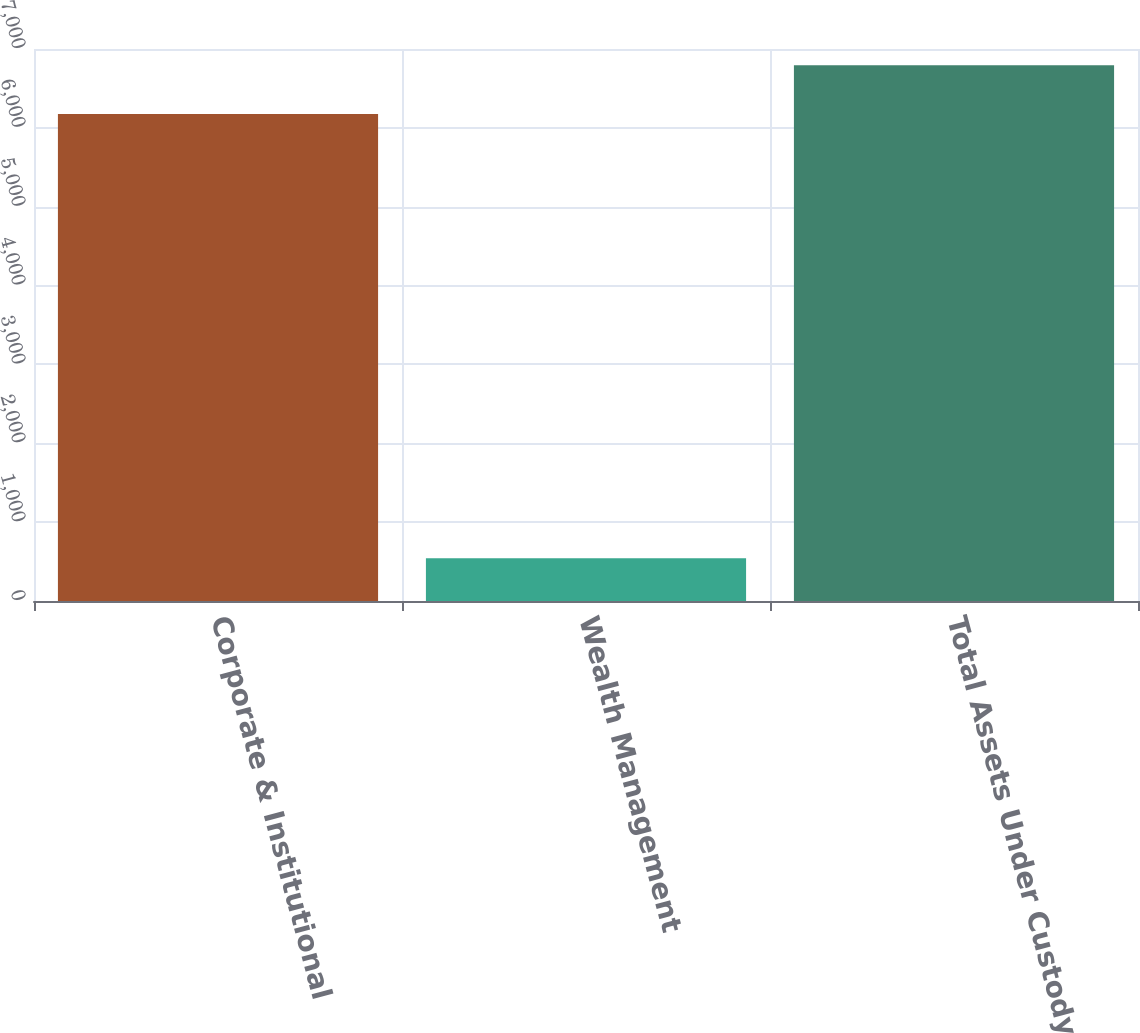Convert chart to OTSL. <chart><loc_0><loc_0><loc_500><loc_500><bar_chart><fcel>Corporate & Institutional<fcel>Wealth Management<fcel>Total Assets Under Custody<nl><fcel>6176.9<fcel>543.6<fcel>6794.59<nl></chart> 